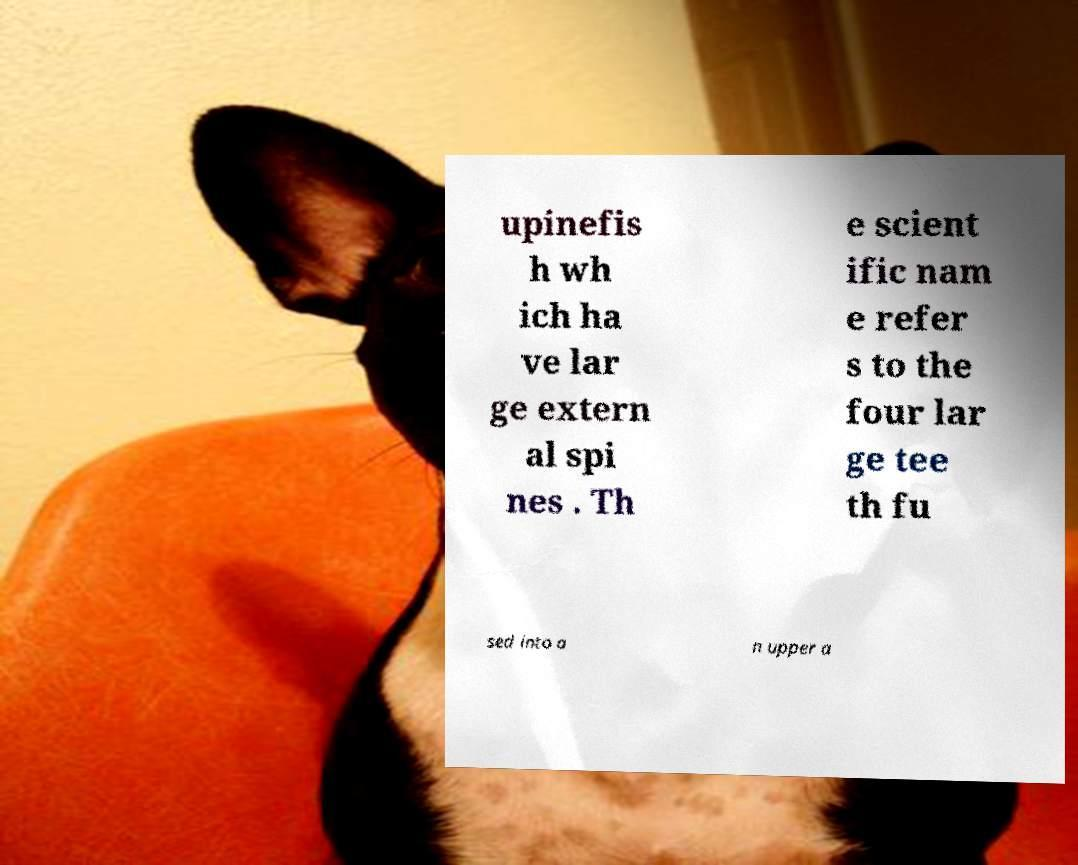Please read and relay the text visible in this image. What does it say? upinefis h wh ich ha ve lar ge extern al spi nes . Th e scient ific nam e refer s to the four lar ge tee th fu sed into a n upper a 